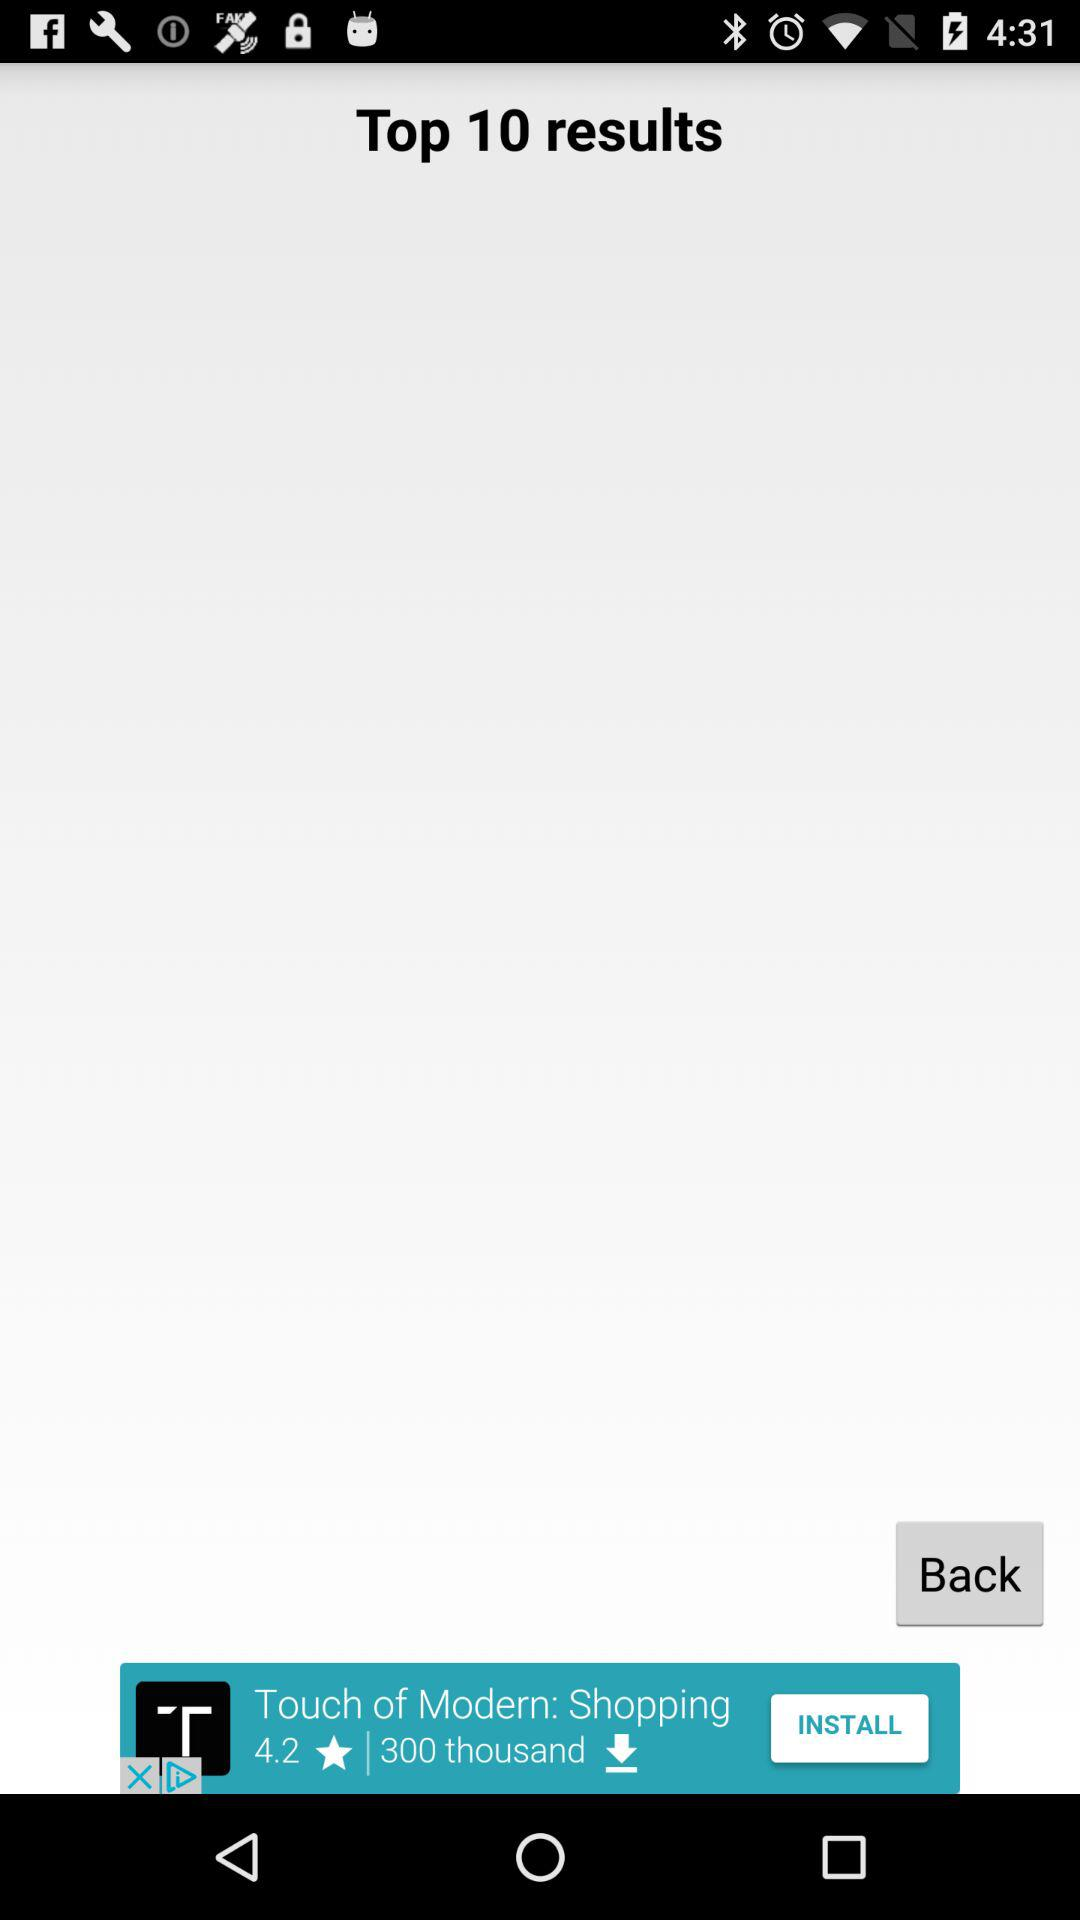What is the number of "Top results"? The number is 10. 